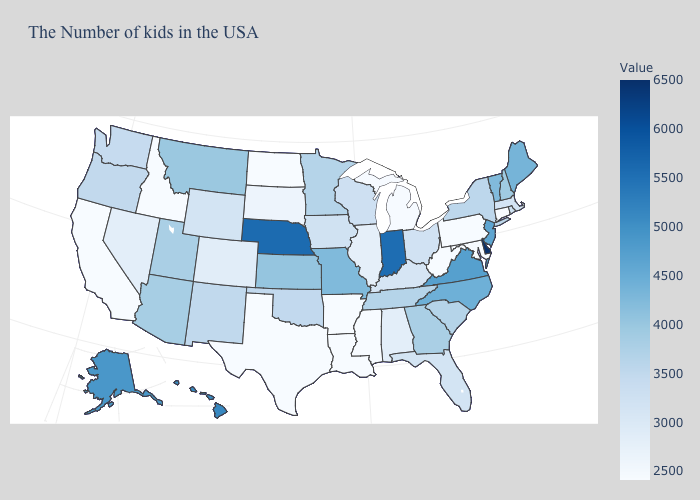Which states hav the highest value in the MidWest?
Concise answer only. Nebraska. Which states have the lowest value in the USA?
Write a very short answer. Connecticut, Maryland, Pennsylvania, West Virginia, Mississippi, Louisiana, Arkansas, Texas, North Dakota, Idaho, California. Which states have the highest value in the USA?
Keep it brief. Delaware. Does Delaware have the highest value in the USA?
Keep it brief. Yes. Does Pennsylvania have a lower value than Wyoming?
Give a very brief answer. Yes. 